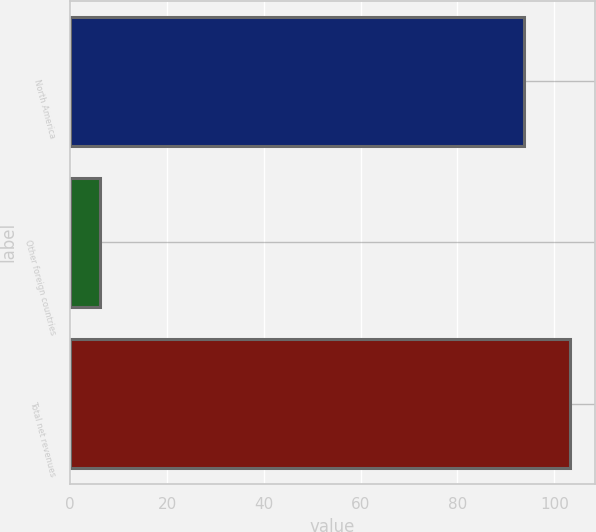<chart> <loc_0><loc_0><loc_500><loc_500><bar_chart><fcel>North America<fcel>Other foreign countries<fcel>Total net revenues<nl><fcel>93.8<fcel>6.2<fcel>103.18<nl></chart> 